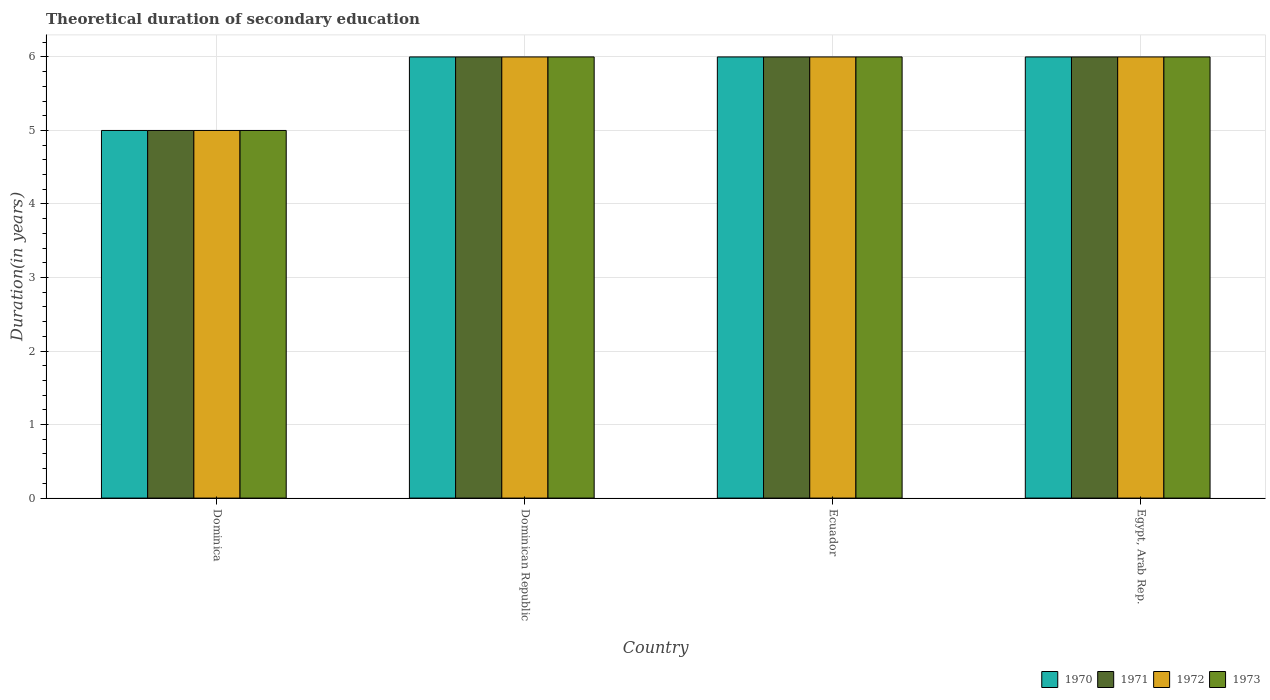How many different coloured bars are there?
Provide a short and direct response. 4. How many groups of bars are there?
Give a very brief answer. 4. Are the number of bars per tick equal to the number of legend labels?
Your answer should be very brief. Yes. How many bars are there on the 1st tick from the left?
Your response must be concise. 4. What is the label of the 4th group of bars from the left?
Provide a short and direct response. Egypt, Arab Rep. In how many cases, is the number of bars for a given country not equal to the number of legend labels?
Your response must be concise. 0. What is the total theoretical duration of secondary education in 1973 in Dominica?
Offer a very short reply. 5. Across all countries, what is the maximum total theoretical duration of secondary education in 1973?
Provide a short and direct response. 6. In which country was the total theoretical duration of secondary education in 1971 maximum?
Make the answer very short. Dominican Republic. In which country was the total theoretical duration of secondary education in 1972 minimum?
Your answer should be very brief. Dominica. What is the total total theoretical duration of secondary education in 1972 in the graph?
Your answer should be compact. 23. What is the average total theoretical duration of secondary education in 1973 per country?
Offer a terse response. 5.75. What is the difference between the total theoretical duration of secondary education of/in 1972 and total theoretical duration of secondary education of/in 1970 in Dominican Republic?
Keep it short and to the point. 0. What is the ratio of the total theoretical duration of secondary education in 1971 in Dominica to that in Ecuador?
Offer a very short reply. 0.83. Is the difference between the total theoretical duration of secondary education in 1972 in Ecuador and Egypt, Arab Rep. greater than the difference between the total theoretical duration of secondary education in 1970 in Ecuador and Egypt, Arab Rep.?
Provide a succinct answer. No. In how many countries, is the total theoretical duration of secondary education in 1973 greater than the average total theoretical duration of secondary education in 1973 taken over all countries?
Offer a very short reply. 3. What does the 3rd bar from the left in Ecuador represents?
Your response must be concise. 1972. Is it the case that in every country, the sum of the total theoretical duration of secondary education in 1970 and total theoretical duration of secondary education in 1971 is greater than the total theoretical duration of secondary education in 1973?
Give a very brief answer. Yes. What is the difference between two consecutive major ticks on the Y-axis?
Give a very brief answer. 1. Are the values on the major ticks of Y-axis written in scientific E-notation?
Provide a short and direct response. No. Does the graph contain any zero values?
Provide a succinct answer. No. Does the graph contain grids?
Your response must be concise. Yes. Where does the legend appear in the graph?
Your response must be concise. Bottom right. How many legend labels are there?
Your answer should be very brief. 4. How are the legend labels stacked?
Provide a short and direct response. Horizontal. What is the title of the graph?
Make the answer very short. Theoretical duration of secondary education. What is the label or title of the X-axis?
Offer a very short reply. Country. What is the label or title of the Y-axis?
Offer a very short reply. Duration(in years). What is the Duration(in years) of 1970 in Dominican Republic?
Your answer should be compact. 6. What is the Duration(in years) of 1971 in Dominican Republic?
Offer a very short reply. 6. What is the Duration(in years) in 1972 in Dominican Republic?
Offer a terse response. 6. What is the Duration(in years) in 1973 in Dominican Republic?
Offer a terse response. 6. What is the Duration(in years) of 1970 in Ecuador?
Offer a very short reply. 6. What is the Duration(in years) in 1971 in Ecuador?
Your response must be concise. 6. What is the Duration(in years) of 1972 in Ecuador?
Offer a very short reply. 6. What is the Duration(in years) in 1972 in Egypt, Arab Rep.?
Provide a succinct answer. 6. Across all countries, what is the maximum Duration(in years) of 1970?
Keep it short and to the point. 6. Across all countries, what is the maximum Duration(in years) in 1973?
Your response must be concise. 6. Across all countries, what is the minimum Duration(in years) of 1970?
Provide a short and direct response. 5. Across all countries, what is the minimum Duration(in years) in 1973?
Your answer should be compact. 5. What is the total Duration(in years) in 1970 in the graph?
Your answer should be compact. 23. What is the total Duration(in years) in 1971 in the graph?
Offer a terse response. 23. What is the total Duration(in years) in 1972 in the graph?
Your answer should be very brief. 23. What is the difference between the Duration(in years) in 1971 in Dominica and that in Ecuador?
Make the answer very short. -1. What is the difference between the Duration(in years) in 1970 in Dominica and that in Egypt, Arab Rep.?
Keep it short and to the point. -1. What is the difference between the Duration(in years) in 1971 in Dominica and that in Egypt, Arab Rep.?
Offer a terse response. -1. What is the difference between the Duration(in years) in 1973 in Dominica and that in Egypt, Arab Rep.?
Offer a terse response. -1. What is the difference between the Duration(in years) in 1970 in Dominican Republic and that in Ecuador?
Offer a very short reply. 0. What is the difference between the Duration(in years) of 1970 in Dominican Republic and that in Egypt, Arab Rep.?
Give a very brief answer. 0. What is the difference between the Duration(in years) of 1971 in Dominican Republic and that in Egypt, Arab Rep.?
Provide a succinct answer. 0. What is the difference between the Duration(in years) in 1970 in Ecuador and that in Egypt, Arab Rep.?
Make the answer very short. 0. What is the difference between the Duration(in years) in 1973 in Ecuador and that in Egypt, Arab Rep.?
Provide a succinct answer. 0. What is the difference between the Duration(in years) of 1970 in Dominica and the Duration(in years) of 1971 in Dominican Republic?
Make the answer very short. -1. What is the difference between the Duration(in years) in 1970 in Dominica and the Duration(in years) in 1973 in Dominican Republic?
Offer a terse response. -1. What is the difference between the Duration(in years) of 1972 in Dominica and the Duration(in years) of 1973 in Dominican Republic?
Your answer should be compact. -1. What is the difference between the Duration(in years) in 1970 in Dominica and the Duration(in years) in 1972 in Ecuador?
Keep it short and to the point. -1. What is the difference between the Duration(in years) in 1970 in Dominica and the Duration(in years) in 1973 in Ecuador?
Ensure brevity in your answer.  -1. What is the difference between the Duration(in years) of 1970 in Dominica and the Duration(in years) of 1971 in Egypt, Arab Rep.?
Offer a very short reply. -1. What is the difference between the Duration(in years) in 1970 in Dominica and the Duration(in years) in 1973 in Egypt, Arab Rep.?
Offer a very short reply. -1. What is the difference between the Duration(in years) in 1972 in Dominica and the Duration(in years) in 1973 in Egypt, Arab Rep.?
Your answer should be compact. -1. What is the difference between the Duration(in years) of 1970 in Dominican Republic and the Duration(in years) of 1971 in Ecuador?
Offer a very short reply. 0. What is the difference between the Duration(in years) of 1970 in Dominican Republic and the Duration(in years) of 1972 in Ecuador?
Make the answer very short. 0. What is the difference between the Duration(in years) in 1970 in Dominican Republic and the Duration(in years) in 1973 in Ecuador?
Ensure brevity in your answer.  0. What is the difference between the Duration(in years) of 1971 in Dominican Republic and the Duration(in years) of 1972 in Ecuador?
Keep it short and to the point. 0. What is the difference between the Duration(in years) in 1971 in Dominican Republic and the Duration(in years) in 1973 in Ecuador?
Keep it short and to the point. 0. What is the difference between the Duration(in years) of 1970 in Dominican Republic and the Duration(in years) of 1971 in Egypt, Arab Rep.?
Ensure brevity in your answer.  0. What is the difference between the Duration(in years) of 1970 in Dominican Republic and the Duration(in years) of 1972 in Egypt, Arab Rep.?
Ensure brevity in your answer.  0. What is the difference between the Duration(in years) of 1971 in Dominican Republic and the Duration(in years) of 1972 in Egypt, Arab Rep.?
Give a very brief answer. 0. What is the difference between the Duration(in years) of 1971 in Dominican Republic and the Duration(in years) of 1973 in Egypt, Arab Rep.?
Your answer should be compact. 0. What is the difference between the Duration(in years) in 1972 in Dominican Republic and the Duration(in years) in 1973 in Egypt, Arab Rep.?
Your answer should be very brief. 0. What is the difference between the Duration(in years) in 1970 in Ecuador and the Duration(in years) in 1971 in Egypt, Arab Rep.?
Offer a very short reply. 0. What is the difference between the Duration(in years) of 1970 in Ecuador and the Duration(in years) of 1972 in Egypt, Arab Rep.?
Ensure brevity in your answer.  0. What is the average Duration(in years) of 1970 per country?
Ensure brevity in your answer.  5.75. What is the average Duration(in years) in 1971 per country?
Keep it short and to the point. 5.75. What is the average Duration(in years) in 1972 per country?
Keep it short and to the point. 5.75. What is the average Duration(in years) of 1973 per country?
Your answer should be compact. 5.75. What is the difference between the Duration(in years) in 1970 and Duration(in years) in 1971 in Dominica?
Your answer should be very brief. 0. What is the difference between the Duration(in years) of 1970 and Duration(in years) of 1973 in Dominica?
Your answer should be compact. 0. What is the difference between the Duration(in years) of 1971 and Duration(in years) of 1972 in Dominica?
Your answer should be very brief. 0. What is the difference between the Duration(in years) in 1971 and Duration(in years) in 1973 in Dominica?
Your response must be concise. 0. What is the difference between the Duration(in years) in 1972 and Duration(in years) in 1973 in Dominica?
Provide a short and direct response. 0. What is the difference between the Duration(in years) in 1970 and Duration(in years) in 1971 in Dominican Republic?
Your answer should be compact. 0. What is the difference between the Duration(in years) in 1970 and Duration(in years) in 1972 in Dominican Republic?
Make the answer very short. 0. What is the difference between the Duration(in years) in 1970 and Duration(in years) in 1972 in Ecuador?
Make the answer very short. 0. What is the difference between the Duration(in years) of 1971 and Duration(in years) of 1972 in Ecuador?
Make the answer very short. 0. What is the difference between the Duration(in years) in 1972 and Duration(in years) in 1973 in Ecuador?
Your answer should be compact. 0. What is the difference between the Duration(in years) of 1970 and Duration(in years) of 1973 in Egypt, Arab Rep.?
Give a very brief answer. 0. What is the difference between the Duration(in years) in 1971 and Duration(in years) in 1973 in Egypt, Arab Rep.?
Give a very brief answer. 0. What is the ratio of the Duration(in years) of 1970 in Dominica to that in Dominican Republic?
Give a very brief answer. 0.83. What is the ratio of the Duration(in years) in 1972 in Dominica to that in Dominican Republic?
Offer a terse response. 0.83. What is the ratio of the Duration(in years) in 1973 in Dominica to that in Dominican Republic?
Ensure brevity in your answer.  0.83. What is the ratio of the Duration(in years) of 1970 in Dominica to that in Ecuador?
Offer a very short reply. 0.83. What is the ratio of the Duration(in years) of 1971 in Dominica to that in Ecuador?
Offer a terse response. 0.83. What is the ratio of the Duration(in years) in 1970 in Dominica to that in Egypt, Arab Rep.?
Make the answer very short. 0.83. What is the ratio of the Duration(in years) in 1972 in Dominica to that in Egypt, Arab Rep.?
Offer a very short reply. 0.83. What is the ratio of the Duration(in years) in 1972 in Dominican Republic to that in Ecuador?
Ensure brevity in your answer.  1. What is the ratio of the Duration(in years) of 1973 in Dominican Republic to that in Ecuador?
Offer a terse response. 1. What is the ratio of the Duration(in years) of 1971 in Dominican Republic to that in Egypt, Arab Rep.?
Provide a succinct answer. 1. What is the ratio of the Duration(in years) of 1971 in Ecuador to that in Egypt, Arab Rep.?
Your answer should be compact. 1. What is the ratio of the Duration(in years) in 1973 in Ecuador to that in Egypt, Arab Rep.?
Give a very brief answer. 1. What is the difference between the highest and the second highest Duration(in years) in 1970?
Offer a terse response. 0. What is the difference between the highest and the second highest Duration(in years) of 1973?
Offer a terse response. 0. What is the difference between the highest and the lowest Duration(in years) of 1971?
Provide a succinct answer. 1. 